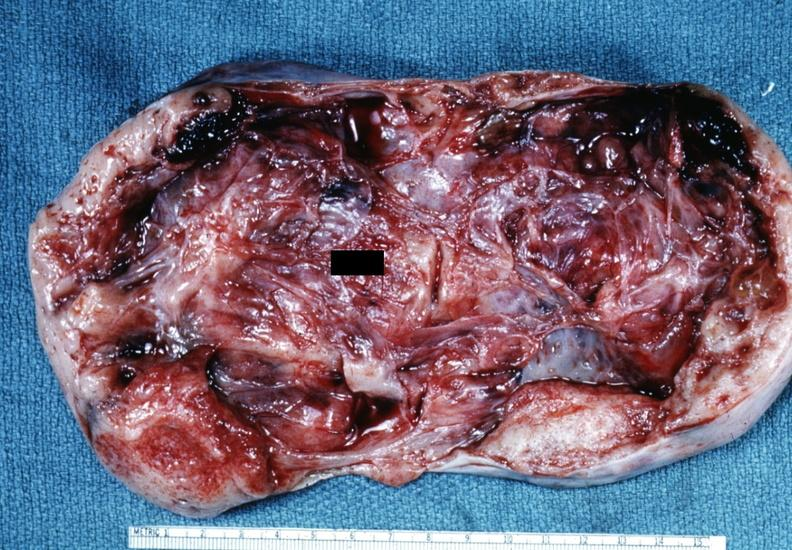s this typical lesion present?
Answer the question using a single word or phrase. No 